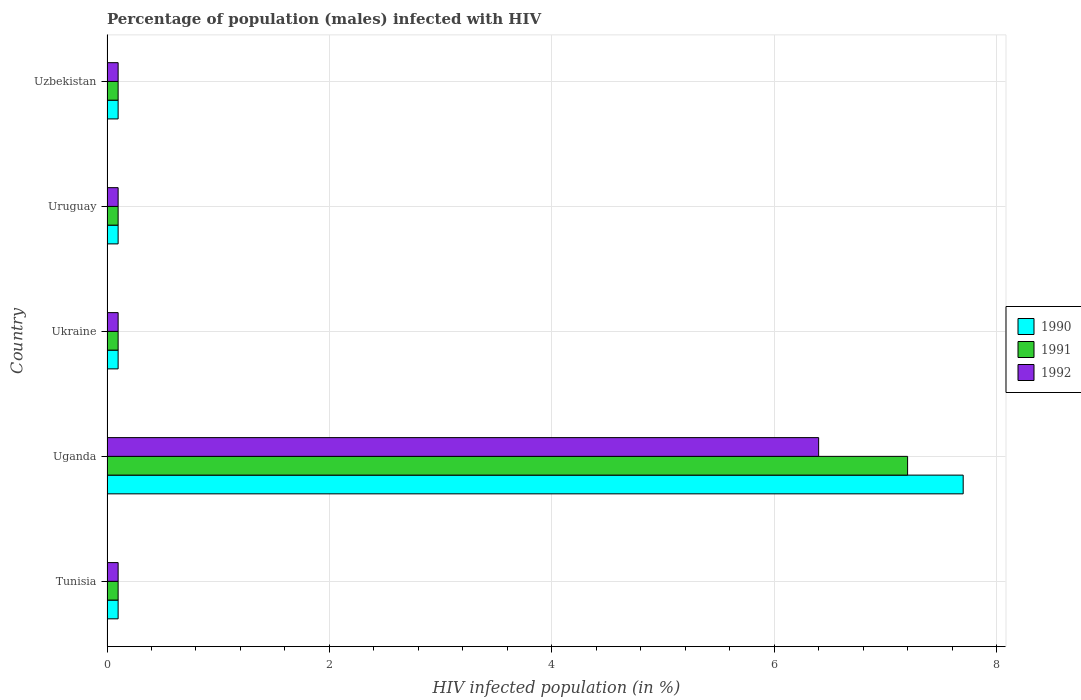How many different coloured bars are there?
Offer a very short reply. 3. How many bars are there on the 2nd tick from the top?
Ensure brevity in your answer.  3. How many bars are there on the 4th tick from the bottom?
Give a very brief answer. 3. What is the label of the 1st group of bars from the top?
Your response must be concise. Uzbekistan. Across all countries, what is the maximum percentage of HIV infected male population in 1992?
Provide a short and direct response. 6.4. Across all countries, what is the minimum percentage of HIV infected male population in 1991?
Your answer should be compact. 0.1. In which country was the percentage of HIV infected male population in 1992 maximum?
Offer a very short reply. Uganda. In which country was the percentage of HIV infected male population in 1990 minimum?
Your answer should be compact. Tunisia. What is the total percentage of HIV infected male population in 1990 in the graph?
Your answer should be very brief. 8.1. What is the difference between the percentage of HIV infected male population in 1992 in Uganda and the percentage of HIV infected male population in 1991 in Uruguay?
Keep it short and to the point. 6.3. What is the average percentage of HIV infected male population in 1992 per country?
Offer a very short reply. 1.36. What is the ratio of the percentage of HIV infected male population in 1991 in Uganda to that in Uzbekistan?
Ensure brevity in your answer.  72. Is the difference between the percentage of HIV infected male population in 1990 in Uganda and Ukraine greater than the difference between the percentage of HIV infected male population in 1991 in Uganda and Ukraine?
Keep it short and to the point. Yes. What is the difference between the highest and the second highest percentage of HIV infected male population in 1990?
Keep it short and to the point. 7.6. What is the difference between the highest and the lowest percentage of HIV infected male population in 1990?
Keep it short and to the point. 7.6. In how many countries, is the percentage of HIV infected male population in 1991 greater than the average percentage of HIV infected male population in 1991 taken over all countries?
Your answer should be very brief. 1. Is the sum of the percentage of HIV infected male population in 1991 in Tunisia and Ukraine greater than the maximum percentage of HIV infected male population in 1992 across all countries?
Ensure brevity in your answer.  No. What does the 1st bar from the bottom in Ukraine represents?
Your response must be concise. 1990. How many bars are there?
Offer a very short reply. 15. How many legend labels are there?
Give a very brief answer. 3. How are the legend labels stacked?
Ensure brevity in your answer.  Vertical. What is the title of the graph?
Offer a very short reply. Percentage of population (males) infected with HIV. What is the label or title of the X-axis?
Your response must be concise. HIV infected population (in %). What is the HIV infected population (in %) in 1990 in Tunisia?
Your response must be concise. 0.1. What is the HIV infected population (in %) of 1990 in Uganda?
Make the answer very short. 7.7. What is the HIV infected population (in %) in 1992 in Uganda?
Your answer should be compact. 6.4. What is the HIV infected population (in %) in 1991 in Ukraine?
Your answer should be very brief. 0.1. What is the HIV infected population (in %) in 1990 in Uruguay?
Keep it short and to the point. 0.1. What is the HIV infected population (in %) in 1991 in Uruguay?
Provide a succinct answer. 0.1. What is the HIV infected population (in %) in 1992 in Uruguay?
Make the answer very short. 0.1. What is the HIV infected population (in %) in 1991 in Uzbekistan?
Offer a very short reply. 0.1. Across all countries, what is the maximum HIV infected population (in %) in 1991?
Keep it short and to the point. 7.2. Across all countries, what is the minimum HIV infected population (in %) in 1991?
Keep it short and to the point. 0.1. What is the difference between the HIV infected population (in %) in 1990 in Tunisia and that in Uganda?
Ensure brevity in your answer.  -7.6. What is the difference between the HIV infected population (in %) in 1991 in Tunisia and that in Uganda?
Provide a succinct answer. -7.1. What is the difference between the HIV infected population (in %) in 1990 in Tunisia and that in Ukraine?
Make the answer very short. 0. What is the difference between the HIV infected population (in %) in 1990 in Tunisia and that in Uruguay?
Offer a terse response. 0. What is the difference between the HIV infected population (in %) in 1992 in Tunisia and that in Uruguay?
Your answer should be very brief. 0. What is the difference between the HIV infected population (in %) of 1991 in Tunisia and that in Uzbekistan?
Your response must be concise. 0. What is the difference between the HIV infected population (in %) of 1992 in Uganda and that in Ukraine?
Make the answer very short. 6.3. What is the difference between the HIV infected population (in %) of 1992 in Uganda and that in Uruguay?
Provide a short and direct response. 6.3. What is the difference between the HIV infected population (in %) in 1991 in Uganda and that in Uzbekistan?
Offer a very short reply. 7.1. What is the difference between the HIV infected population (in %) of 1992 in Uganda and that in Uzbekistan?
Ensure brevity in your answer.  6.3. What is the difference between the HIV infected population (in %) in 1991 in Ukraine and that in Uzbekistan?
Your answer should be very brief. 0. What is the difference between the HIV infected population (in %) in 1990 in Uruguay and that in Uzbekistan?
Make the answer very short. 0. What is the difference between the HIV infected population (in %) in 1990 in Tunisia and the HIV infected population (in %) in 1991 in Uganda?
Provide a short and direct response. -7.1. What is the difference between the HIV infected population (in %) in 1991 in Tunisia and the HIV infected population (in %) in 1992 in Uganda?
Provide a short and direct response. -6.3. What is the difference between the HIV infected population (in %) of 1990 in Tunisia and the HIV infected population (in %) of 1991 in Ukraine?
Keep it short and to the point. 0. What is the difference between the HIV infected population (in %) of 1991 in Tunisia and the HIV infected population (in %) of 1992 in Ukraine?
Your response must be concise. 0. What is the difference between the HIV infected population (in %) in 1991 in Tunisia and the HIV infected population (in %) in 1992 in Uruguay?
Provide a succinct answer. 0. What is the difference between the HIV infected population (in %) in 1990 in Tunisia and the HIV infected population (in %) in 1991 in Uzbekistan?
Offer a terse response. 0. What is the difference between the HIV infected population (in %) of 1990 in Uganda and the HIV infected population (in %) of 1992 in Ukraine?
Make the answer very short. 7.6. What is the difference between the HIV infected population (in %) of 1991 in Uganda and the HIV infected population (in %) of 1992 in Ukraine?
Provide a succinct answer. 7.1. What is the difference between the HIV infected population (in %) of 1990 in Uganda and the HIV infected population (in %) of 1992 in Uzbekistan?
Keep it short and to the point. 7.6. What is the difference between the HIV infected population (in %) in 1991 in Uganda and the HIV infected population (in %) in 1992 in Uzbekistan?
Your response must be concise. 7.1. What is the difference between the HIV infected population (in %) in 1990 in Ukraine and the HIV infected population (in %) in 1991 in Uruguay?
Keep it short and to the point. 0. What is the difference between the HIV infected population (in %) in 1990 in Ukraine and the HIV infected population (in %) in 1991 in Uzbekistan?
Offer a terse response. 0. What is the difference between the HIV infected population (in %) in 1990 in Ukraine and the HIV infected population (in %) in 1992 in Uzbekistan?
Provide a succinct answer. 0. What is the difference between the HIV infected population (in %) in 1990 in Uruguay and the HIV infected population (in %) in 1991 in Uzbekistan?
Your response must be concise. 0. What is the difference between the HIV infected population (in %) in 1991 in Uruguay and the HIV infected population (in %) in 1992 in Uzbekistan?
Your answer should be compact. 0. What is the average HIV infected population (in %) of 1990 per country?
Provide a succinct answer. 1.62. What is the average HIV infected population (in %) of 1991 per country?
Your answer should be compact. 1.52. What is the average HIV infected population (in %) in 1992 per country?
Provide a succinct answer. 1.36. What is the difference between the HIV infected population (in %) in 1990 and HIV infected population (in %) in 1992 in Tunisia?
Ensure brevity in your answer.  0. What is the difference between the HIV infected population (in %) in 1990 and HIV infected population (in %) in 1992 in Ukraine?
Your answer should be compact. 0. What is the difference between the HIV infected population (in %) in 1991 and HIV infected population (in %) in 1992 in Ukraine?
Your answer should be compact. 0. What is the difference between the HIV infected population (in %) of 1990 and HIV infected population (in %) of 1991 in Uruguay?
Your answer should be compact. 0. What is the difference between the HIV infected population (in %) in 1990 and HIV infected population (in %) in 1992 in Uruguay?
Your answer should be compact. 0. What is the difference between the HIV infected population (in %) in 1990 and HIV infected population (in %) in 1991 in Uzbekistan?
Your response must be concise. 0. What is the difference between the HIV infected population (in %) of 1991 and HIV infected population (in %) of 1992 in Uzbekistan?
Offer a very short reply. 0. What is the ratio of the HIV infected population (in %) in 1990 in Tunisia to that in Uganda?
Provide a succinct answer. 0.01. What is the ratio of the HIV infected population (in %) of 1991 in Tunisia to that in Uganda?
Give a very brief answer. 0.01. What is the ratio of the HIV infected population (in %) of 1992 in Tunisia to that in Uganda?
Make the answer very short. 0.02. What is the ratio of the HIV infected population (in %) in 1992 in Tunisia to that in Ukraine?
Your answer should be compact. 1. What is the ratio of the HIV infected population (in %) in 1991 in Tunisia to that in Uruguay?
Give a very brief answer. 1. What is the ratio of the HIV infected population (in %) in 1992 in Tunisia to that in Uruguay?
Keep it short and to the point. 1. What is the ratio of the HIV infected population (in %) of 1990 in Tunisia to that in Uzbekistan?
Provide a succinct answer. 1. What is the ratio of the HIV infected population (in %) in 1991 in Tunisia to that in Uzbekistan?
Keep it short and to the point. 1. What is the ratio of the HIV infected population (in %) in 1992 in Tunisia to that in Uzbekistan?
Ensure brevity in your answer.  1. What is the ratio of the HIV infected population (in %) of 1990 in Uganda to that in Uruguay?
Offer a terse response. 77. What is the ratio of the HIV infected population (in %) in 1992 in Uganda to that in Uruguay?
Offer a very short reply. 64. What is the ratio of the HIV infected population (in %) in 1991 in Uganda to that in Uzbekistan?
Offer a very short reply. 72. What is the ratio of the HIV infected population (in %) in 1991 in Ukraine to that in Uruguay?
Your answer should be compact. 1. What is the ratio of the HIV infected population (in %) of 1991 in Ukraine to that in Uzbekistan?
Make the answer very short. 1. What is the ratio of the HIV infected population (in %) in 1992 in Ukraine to that in Uzbekistan?
Keep it short and to the point. 1. What is the ratio of the HIV infected population (in %) in 1991 in Uruguay to that in Uzbekistan?
Make the answer very short. 1. What is the ratio of the HIV infected population (in %) of 1992 in Uruguay to that in Uzbekistan?
Offer a very short reply. 1. What is the difference between the highest and the second highest HIV infected population (in %) in 1990?
Ensure brevity in your answer.  7.6. What is the difference between the highest and the lowest HIV infected population (in %) of 1991?
Your response must be concise. 7.1. 